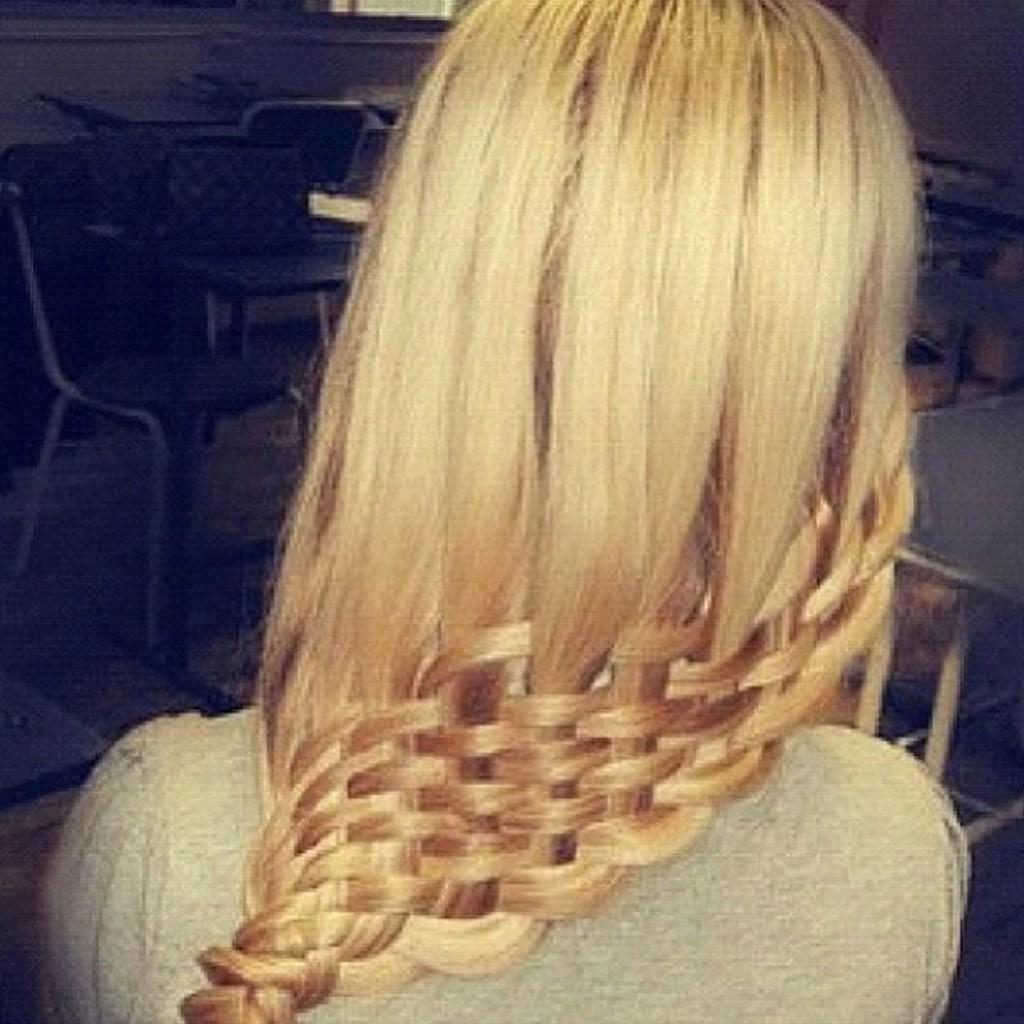Who or what is present in the image? There is a person in the image. What can be seen in the background of the image? There are tables and chairs in the background of the image. What type of whip is being used by the person in the image? There is no whip present in the image. When is the recess taking place in the image? There is no indication of a recess or any specific time in the image. 